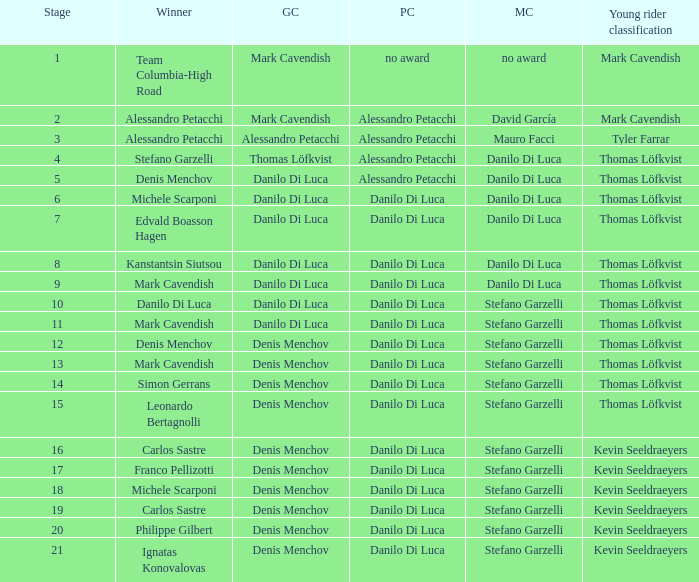When thomas löfkvist is the  young rider classification and alessandro petacchi is the points classification who are the general classifications?  Thomas Löfkvist, Danilo Di Luca. 